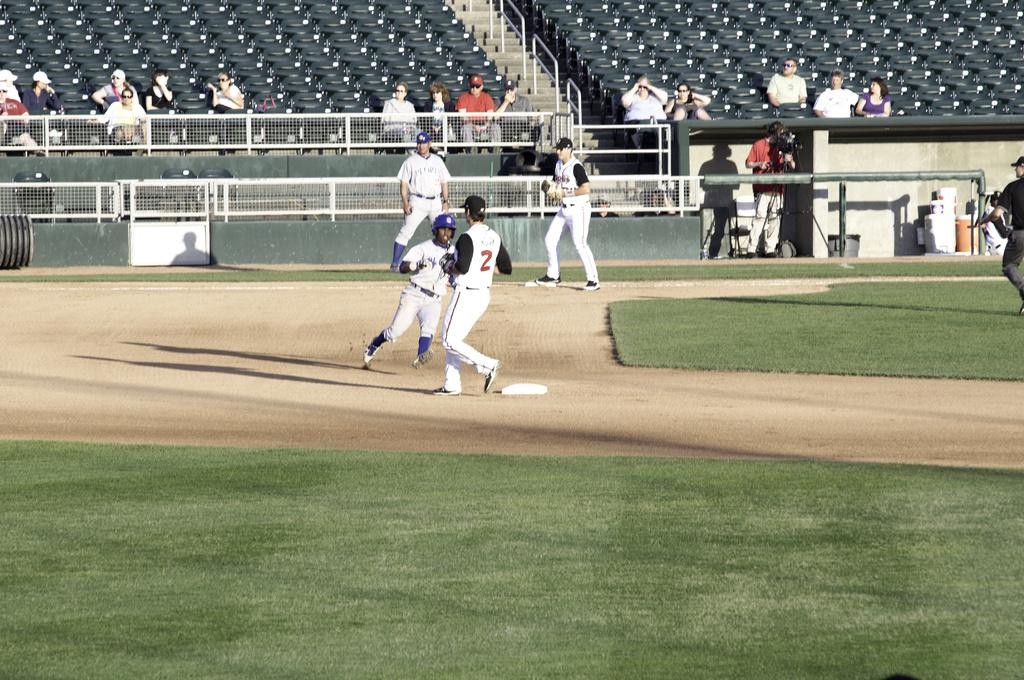What is happening in the image? There are people on the ground in the image. What can be seen in the background of the image? There is a fence and chairs in the background of the image. What type of zinc is being used to build the house in the image? There is no house present in the image, and therefore no zinc can be observed. 